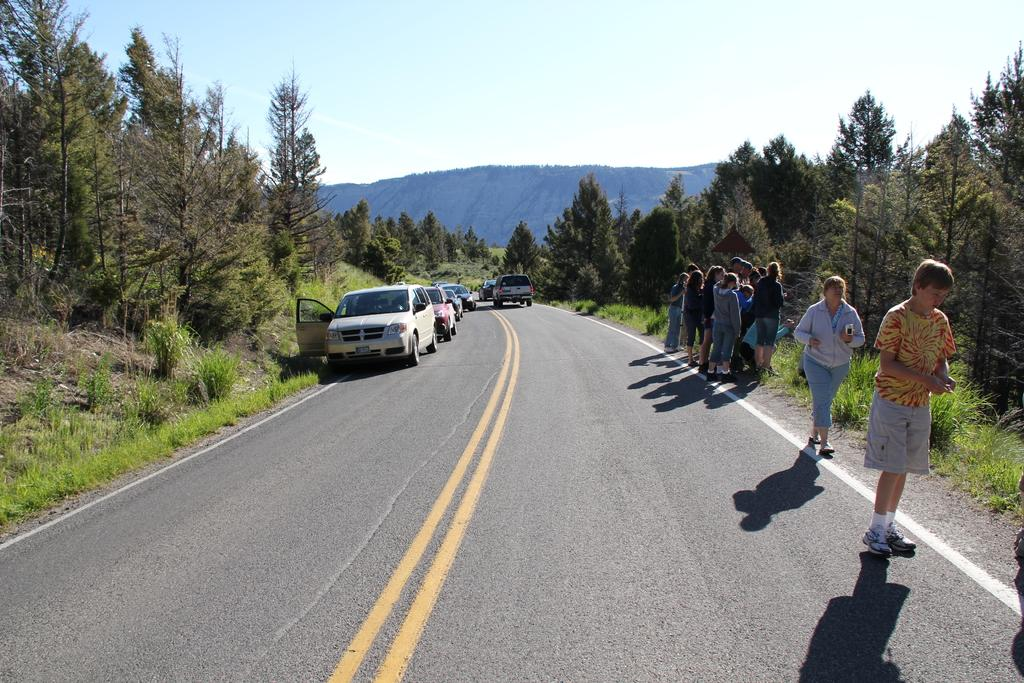What can be seen on the road in the image? There are vehicles on the road in the image. What else is present in the image besides the vehicles? There are people standing in the image. What is visible in the background of the image? The sky, hills, trees, plants, and grass are present in the background of the image. What type of ear is visible on the hill in the image? There is no ear present in the image; the background features hills, trees, plants, and grass. What is the people's level of fear in the image? There is no indication of fear in the image; people are simply standing. 